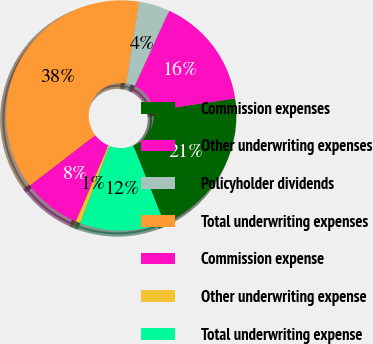Convert chart. <chart><loc_0><loc_0><loc_500><loc_500><pie_chart><fcel>Commission expenses<fcel>Other underwriting expenses<fcel>Policyholder dividends<fcel>Total underwriting expenses<fcel>Commission expense<fcel>Other underwriting expense<fcel>Total underwriting expense<nl><fcel>21.31%<fcel>15.81%<fcel>4.38%<fcel>37.89%<fcel>8.11%<fcel>0.66%<fcel>11.83%<nl></chart> 